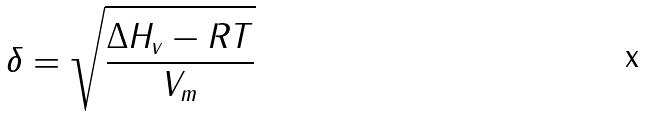Convert formula to latex. <formula><loc_0><loc_0><loc_500><loc_500>\delta = \sqrt { \frac { \Delta H _ { v } - R T } { V _ { m } } }</formula> 